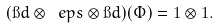Convert formula to latex. <formula><loc_0><loc_0><loc_500><loc_500>( \i d \otimes \ e p s \otimes \i d ) ( \Phi ) = 1 \otimes 1 .</formula> 